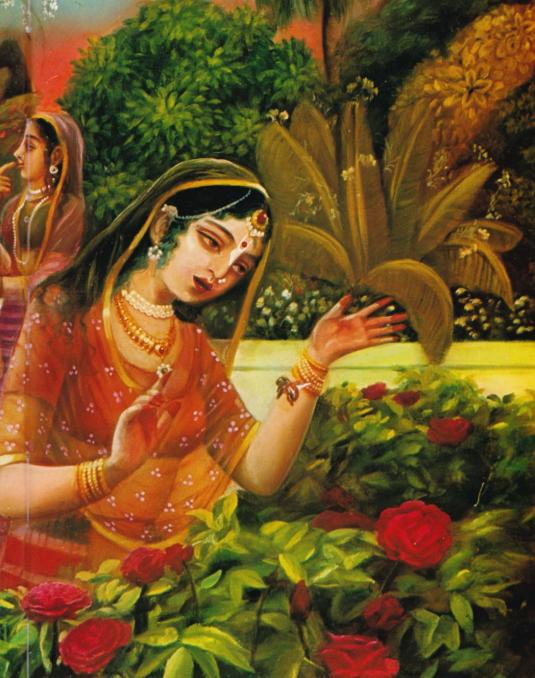Imagine a dialogue between the two women in the painting. What might they be saying to each other? Primary Woman: 'Look at how these roses bloom under the warm sun, embracing the essence of life and devotion. Each petal seems to whisper stories of the past.'
Secondary Woman: 'Indeed, they do. These flowers remind me of the tales our grandmothers told us, of love and longing, of nature's unfathomable beauty. Perhaps we are meant to preserve these stories and cherish these moments together.' How might these conversations reflect the cultural values of the time? These imagined conversations reflect the cultural values of timeless appreciation for nature, storytelling, and the importance of traditions. In many Indian cultural contexts, nature is revered, and stories passed down through generations hold significant value. The dialogue captures themes of devotion, communal memory, and the perpetuation of cultural heritage, underscoring the interconnectedness of beauty, history, and familial bonds. 